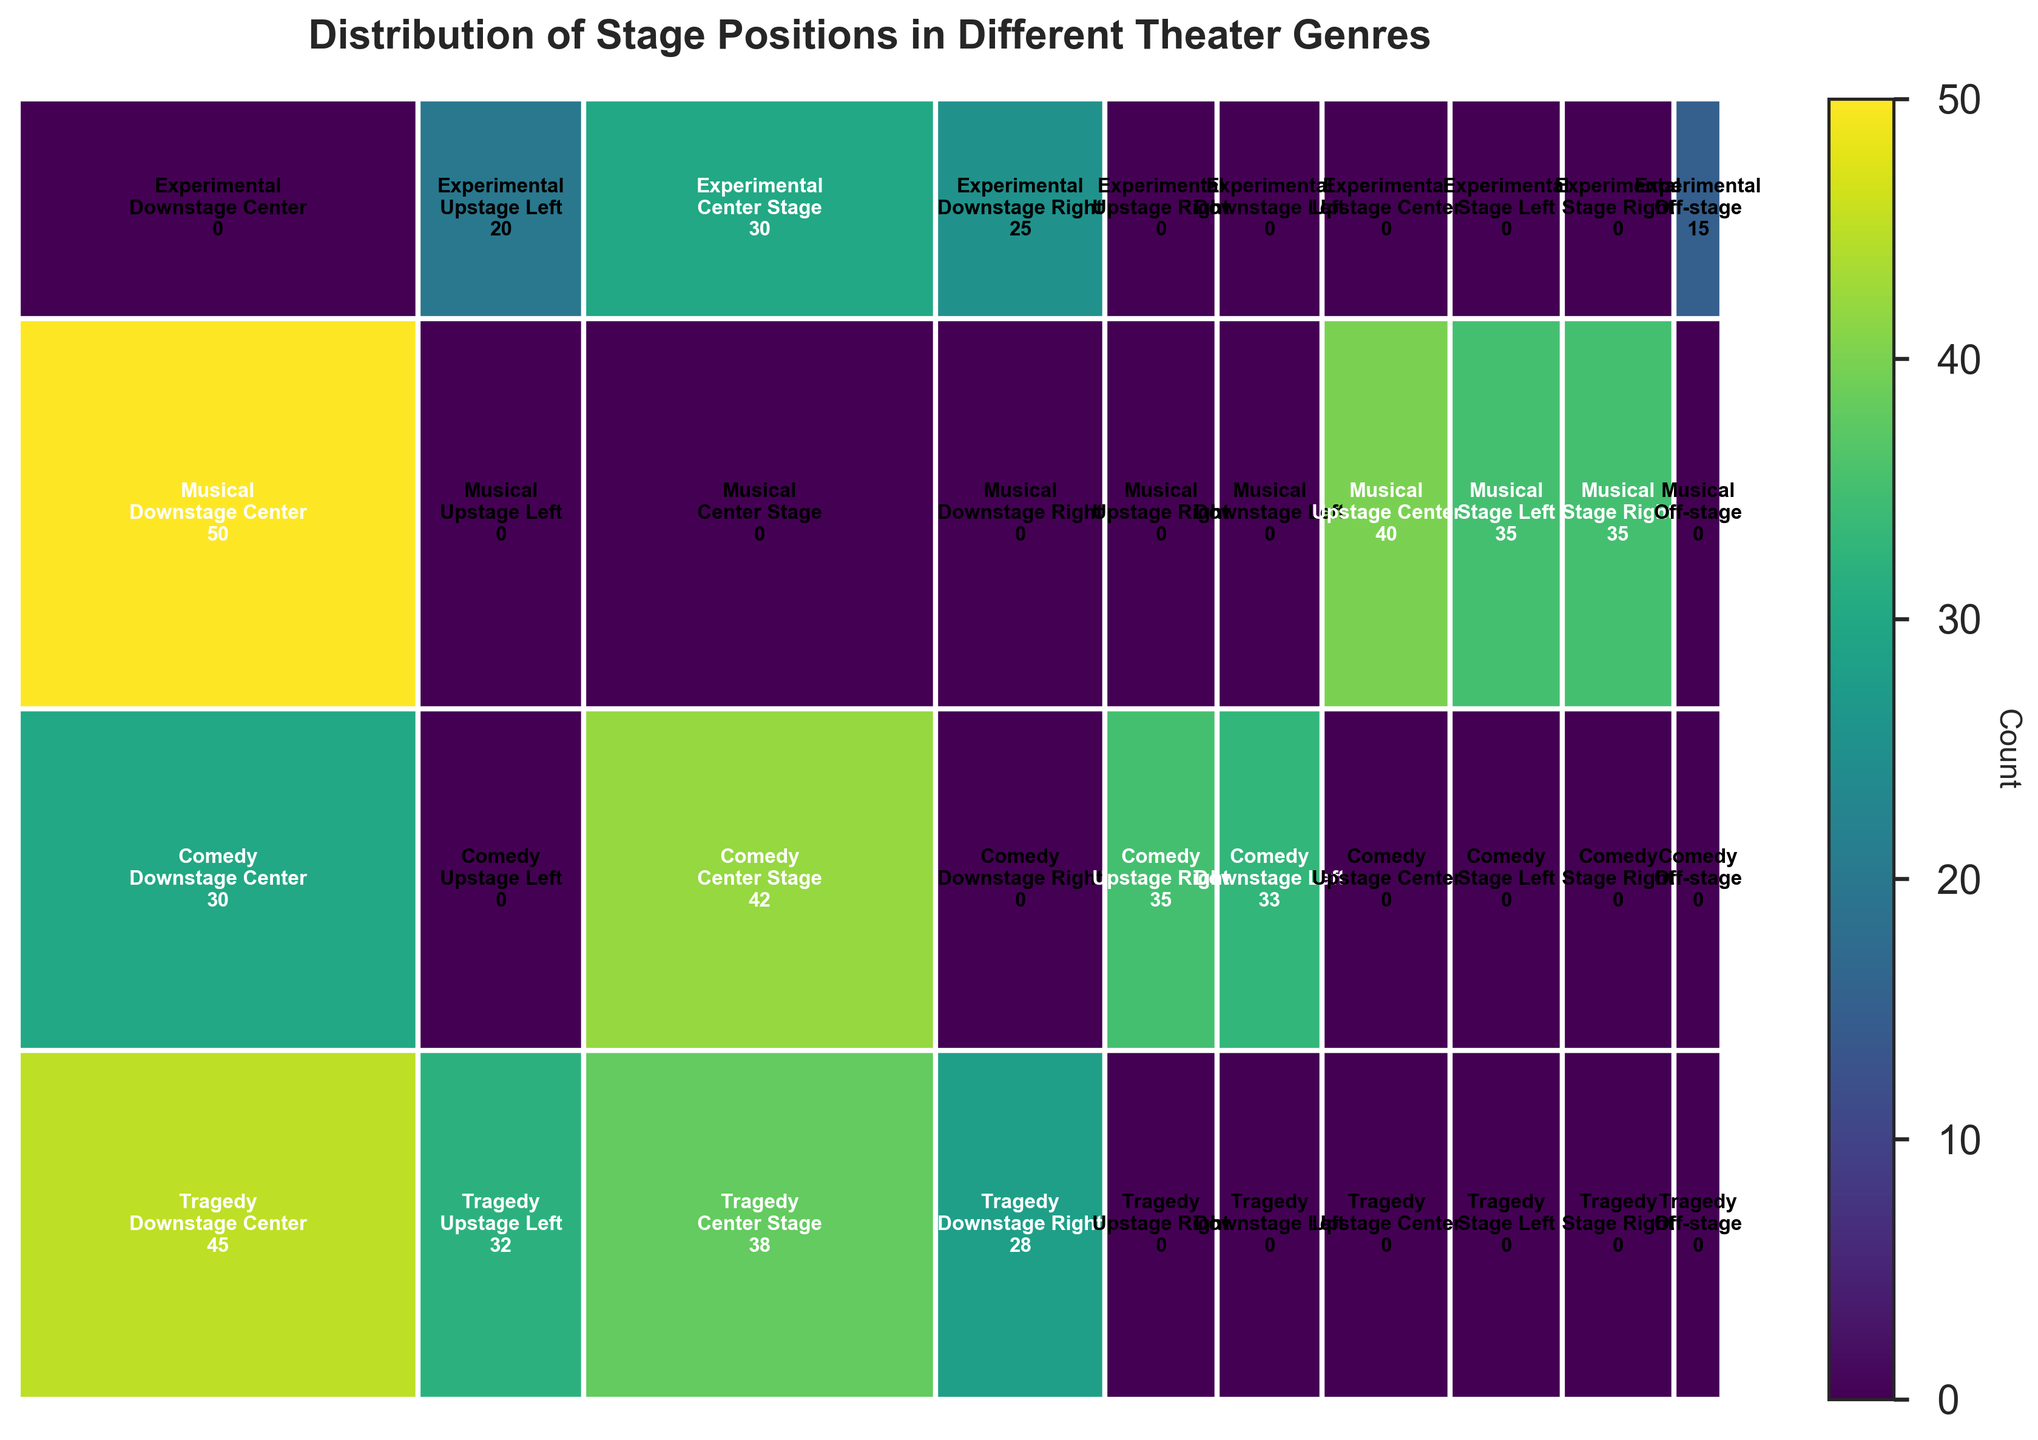What's the title of the plot? Look at the top of the figure where the title is usually placed, and you'll find "Distribution of Stage Positions in Different Theater Genres."
Answer: Distribution of Stage Positions in Different Theater Genres Which position has the highest count across all genres? By looking at the rectangles, the darkest color, which indicates the highest count, is found under "Musical" and "Downstage Center." The count is 50.
Answer: Downstage Center (Musical) How many genres have positions with counts greater than 40? Identify the rectangles with counts greater than 40 across all genres: "Tragedy" has none, "Comedy" has Center Stage, "Musical" has Downstage Center and Upstage Center. So there are 2 genres.
Answer: 2 Which position is least used in Experimental genre? Locate the section for "Experimental" and find the rectangle with the smallest count. The position is "Off-stage," and the count is 15.
Answer: Off-stage Compare the counts for "Center Stage" across all genres. Which genre has the highest count? Look at the "Center Stage" positions across different genres and compare their counts: Tragedy (38), Comedy (42), Experimental (30). The highest is for Comedy with a count of 42.
Answer: Comedy Which two genres have the closest counts for "Downstage Center"? Check the "Downstage Center" counts in each genre: Tragedy (45), Comedy (30), Musical (50), and find that Comedy (30) and Musical (50) are closest.
Answer: Comedy and Musical What's the sum of counts for "Upstage Left" across all genres? Add the counts for "Upstage Left" in each genre: Tragedy (32) + Experimental (20) = 52.
Answer: 52 Which genre has the highest total count for all stage positions? Sum the counts for positions in each genre: Tragedy (143), Comedy (140), Musical (160), Experimental (90). "Musical" clearly has the highest total count (160).
Answer: Musical For Tragedy and Comedy, compare the counts for "Downstage Center" and determine which genre has higher count. Compare "Downstage Center" counts between Tragedy (45) and Comedy (30). Tragedy has the higher count.
Answer: Tragedy 